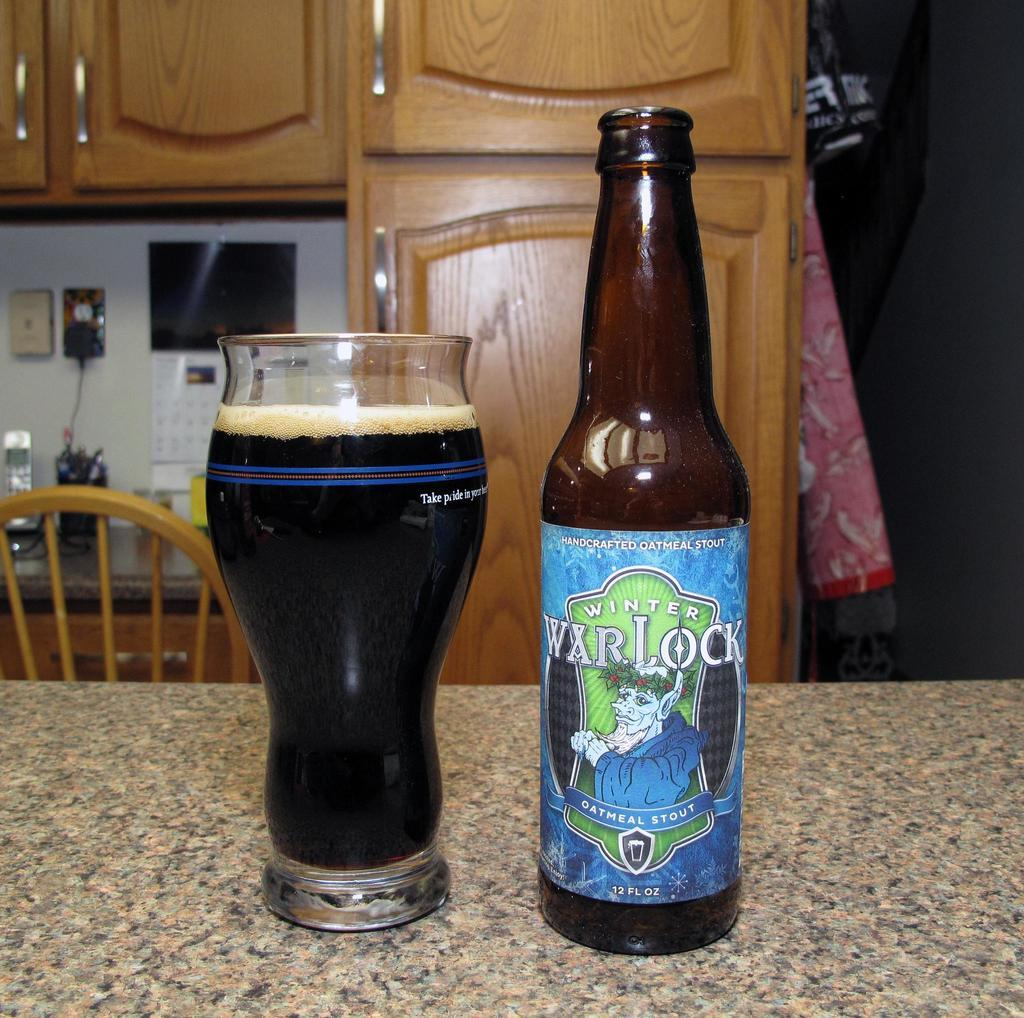<image>
Write a terse but informative summary of the picture. A bottle of Warlock oatmeal stout is next to a full glass of the stout. 